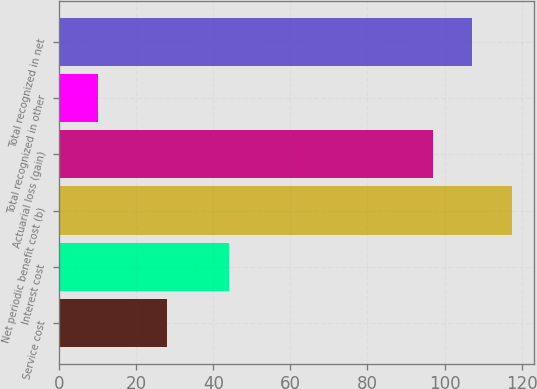<chart> <loc_0><loc_0><loc_500><loc_500><bar_chart><fcel>Service cost<fcel>Interest cost<fcel>Net periodic benefit cost (b)<fcel>Actuarial loss (gain)<fcel>Total recognized in other<fcel>Total recognized in net<nl><fcel>28<fcel>44<fcel>117.4<fcel>97<fcel>10<fcel>107.2<nl></chart> 